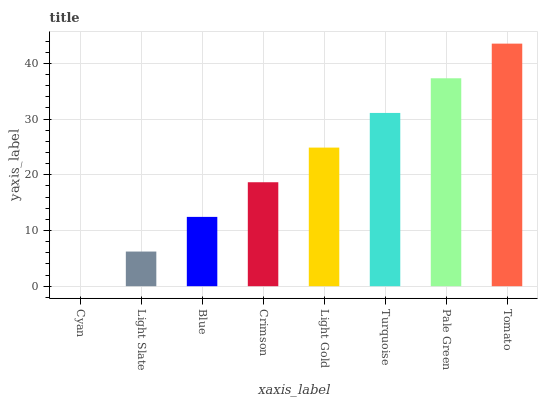Is Cyan the minimum?
Answer yes or no. Yes. Is Tomato the maximum?
Answer yes or no. Yes. Is Light Slate the minimum?
Answer yes or no. No. Is Light Slate the maximum?
Answer yes or no. No. Is Light Slate greater than Cyan?
Answer yes or no. Yes. Is Cyan less than Light Slate?
Answer yes or no. Yes. Is Cyan greater than Light Slate?
Answer yes or no. No. Is Light Slate less than Cyan?
Answer yes or no. No. Is Light Gold the high median?
Answer yes or no. Yes. Is Crimson the low median?
Answer yes or no. Yes. Is Tomato the high median?
Answer yes or no. No. Is Pale Green the low median?
Answer yes or no. No. 